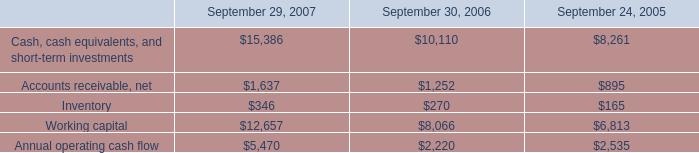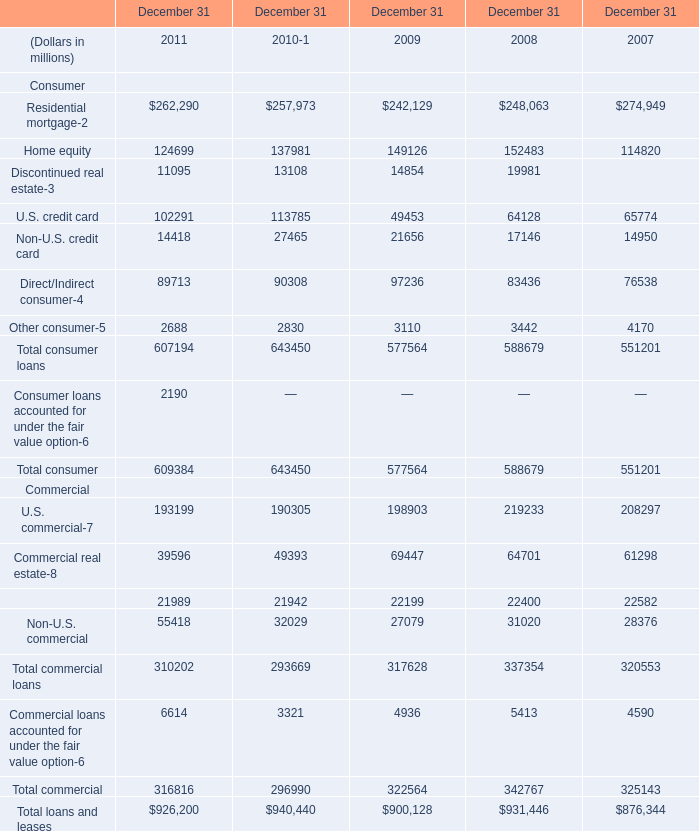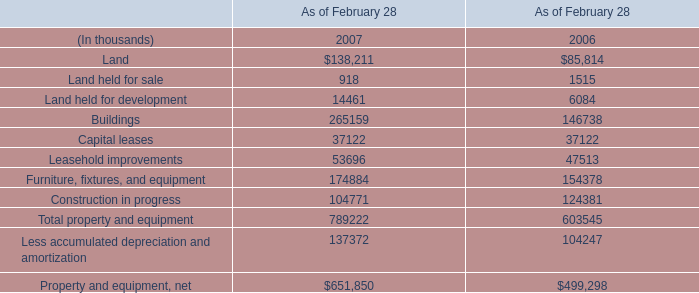What is the sum of Accounts receivable, net of September 29, 2007, and Commercial lease financing Commercial of December 31 2009 ? 
Computations: (1637.0 + 22199.0)
Answer: 23836.0. 